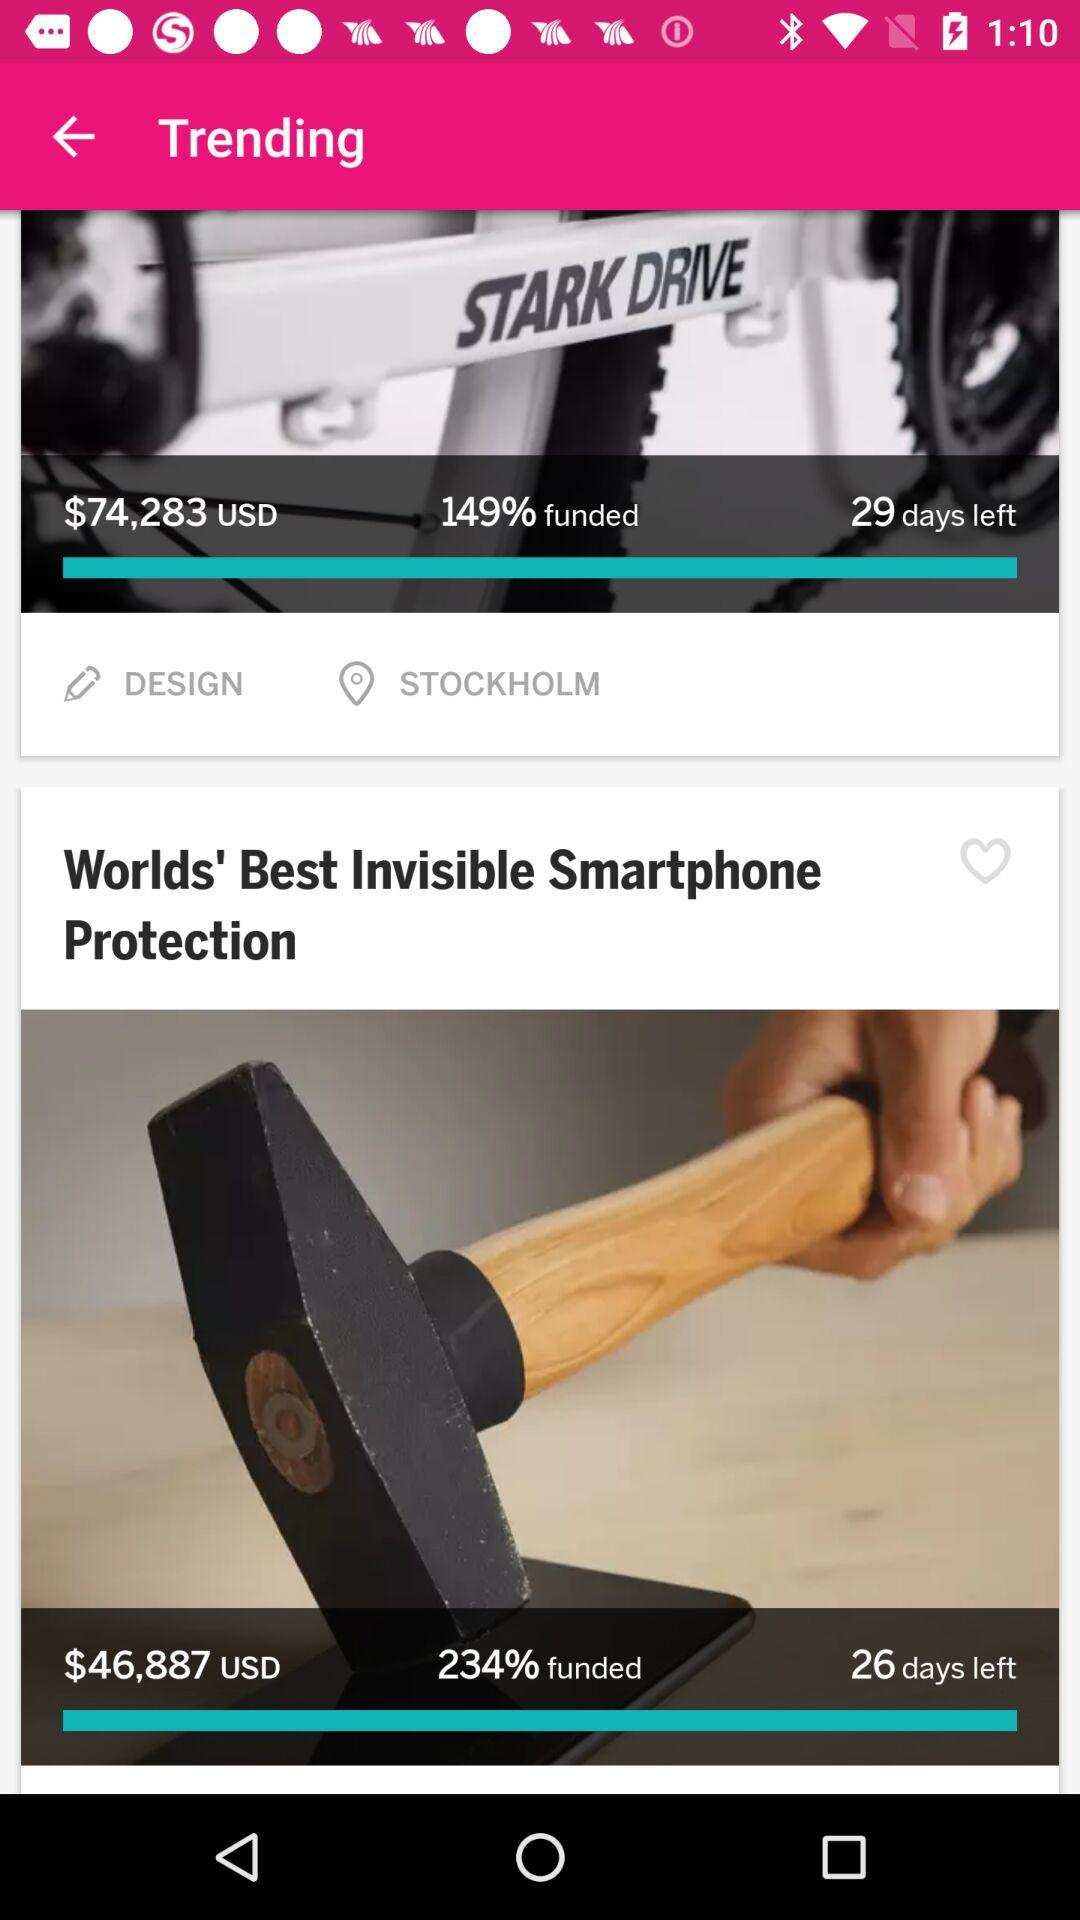What is the funded percentage of "Worlds' Best Invisible Smartphone Protection"? The funded percentage is 234. 